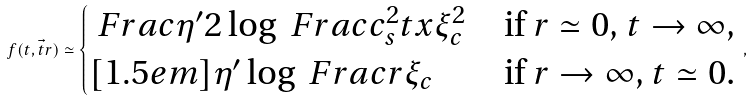Convert formula to latex. <formula><loc_0><loc_0><loc_500><loc_500>f ( t , \vec { t } { r } ) \simeq \begin{cases} \ F r a c { \eta ^ { \prime } } { 2 } \log \ F r a c { c _ { s } ^ { 2 } t } { x \xi _ { c } ^ { 2 } } & \text {if $r\simeq 0$, $t \to \infty$,} \\ [ 1 . 5 e m ] \eta ^ { \prime } \log \ F r a c { r } { \xi _ { c } } & \text {if $r \to \infty$, $t \simeq    0$.} \end{cases} \, ,</formula> 